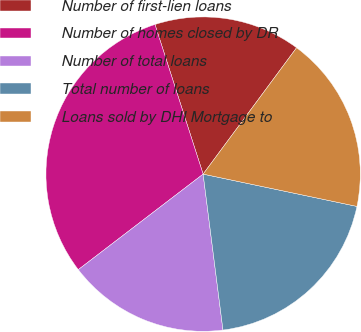<chart> <loc_0><loc_0><loc_500><loc_500><pie_chart><fcel>Number of first-lien loans<fcel>Number of homes closed by DR<fcel>Number of total loans<fcel>Total number of loans<fcel>Loans sold by DHI Mortgage to<nl><fcel>15.09%<fcel>30.44%<fcel>16.62%<fcel>19.69%<fcel>18.16%<nl></chart> 